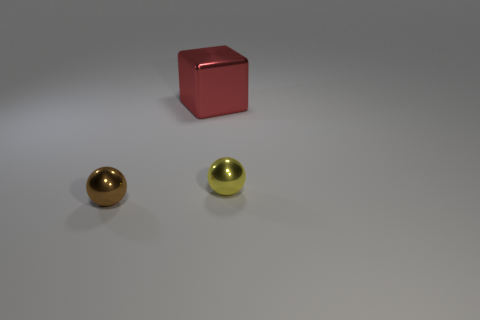Can you tell me more about the colors and shapes visible in this image? Certainly! The image displays three distinct objects with different colors and shapes. There is a red cube with a surface that reflects light, indicating a somewhat shiny material. Additionally, two polished spheres are present: one with a gold hue and the other with a silver tone. The three objects are placed on what appears to be a flat surface with a neutral tone, likely meant to highlight the objects' features without distraction. 